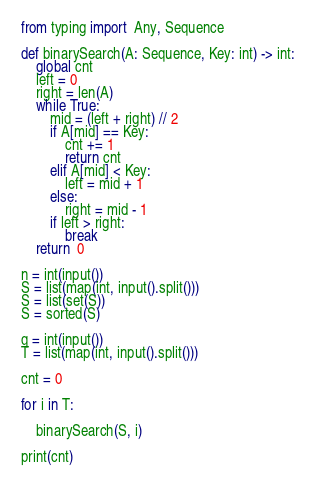Convert code to text. <code><loc_0><loc_0><loc_500><loc_500><_Python_>from typing import  Any, Sequence

def binarySearch(A: Sequence, Key: int) -> int:
    global cnt
    left = 0
    right = len(A)
    while True:
        mid = (left + right) // 2
        if A[mid] == Key:
            cnt += 1
            return cnt
        elif A[mid] < Key:
            left = mid + 1
        else:
            right = mid - 1
        if left > right:
            break
    return  0

n = int(input())
S = list(map(int, input().split()))
S = list(set(S))
S = sorted(S)

q = int(input())
T = list(map(int, input().split()))

cnt = 0

for i in T:

    binarySearch(S, i)

print(cnt)


</code> 